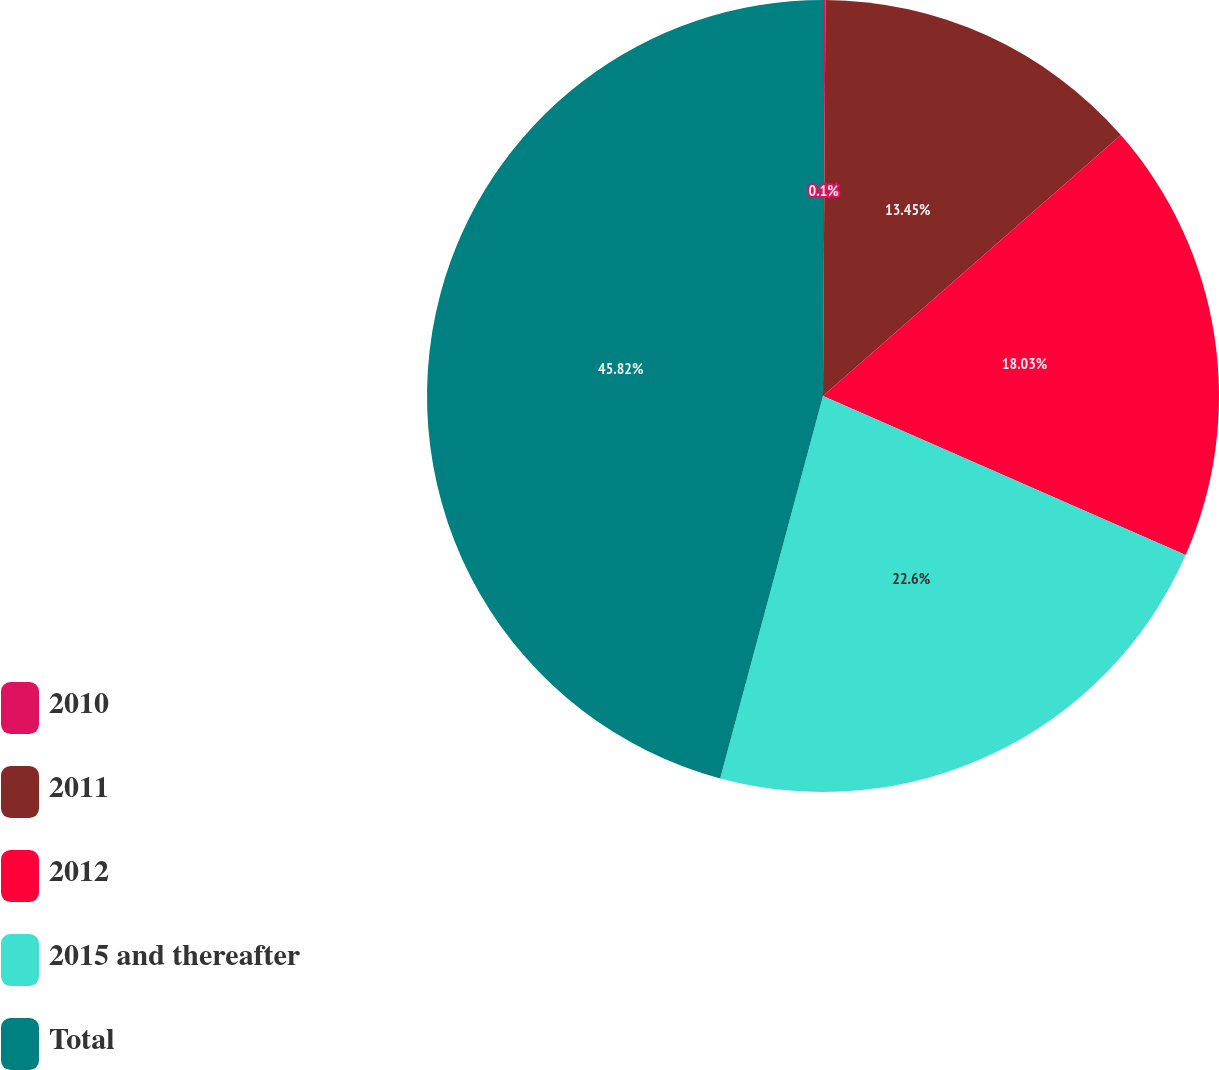<chart> <loc_0><loc_0><loc_500><loc_500><pie_chart><fcel>2010<fcel>2011<fcel>2012<fcel>2015 and thereafter<fcel>Total<nl><fcel>0.1%<fcel>13.45%<fcel>18.03%<fcel>22.6%<fcel>45.82%<nl></chart> 